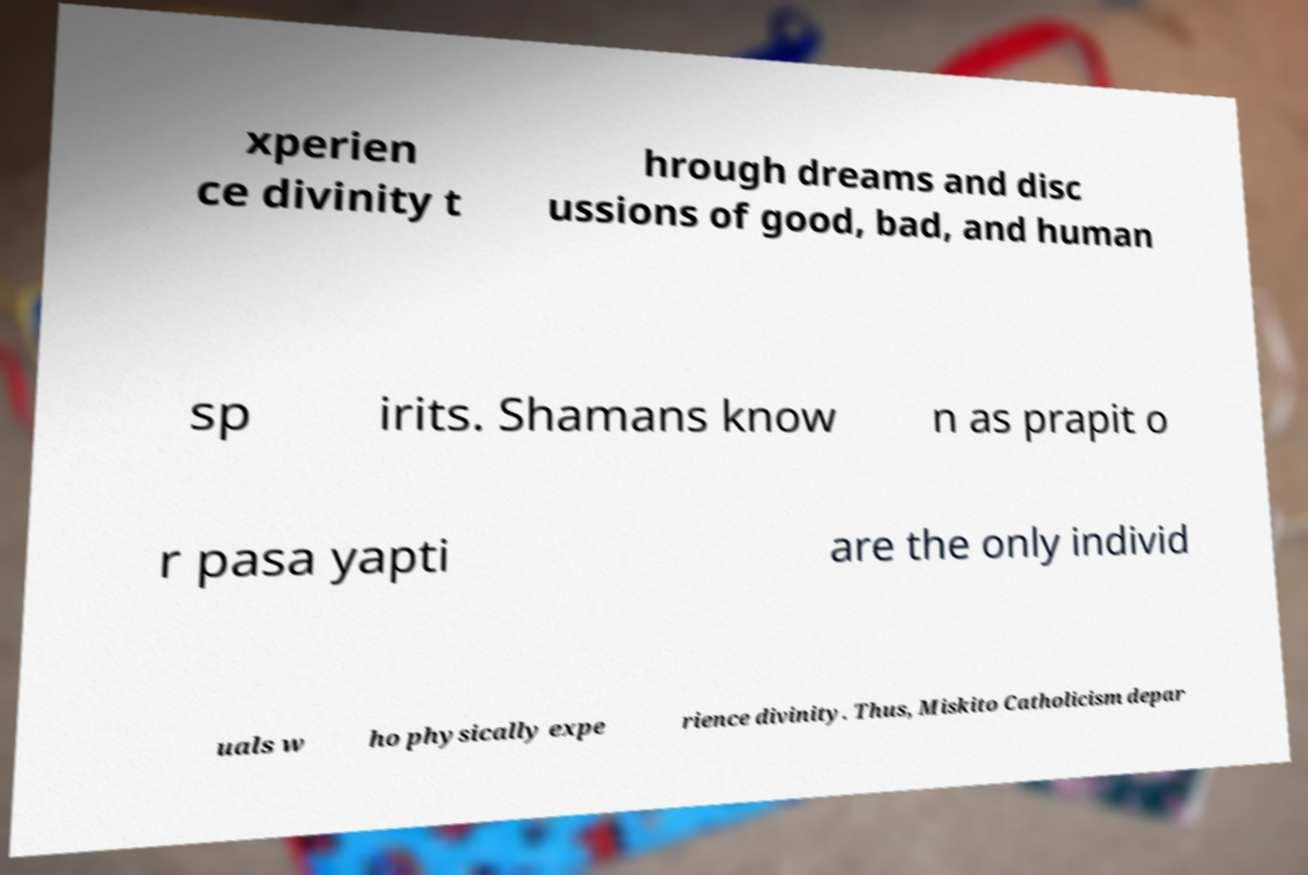Please identify and transcribe the text found in this image. xperien ce divinity t hrough dreams and disc ussions of good, bad, and human sp irits. Shamans know n as prapit o r pasa yapti are the only individ uals w ho physically expe rience divinity. Thus, Miskito Catholicism depar 